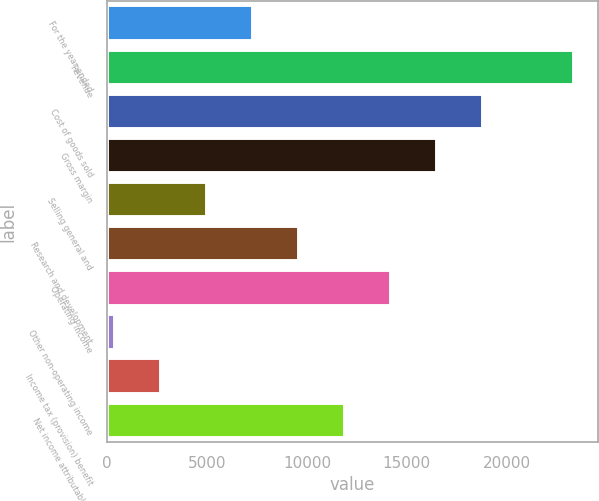Convert chart to OTSL. <chart><loc_0><loc_0><loc_500><loc_500><bar_chart><fcel>For the year ended<fcel>Revenue<fcel>Cost of goods sold<fcel>Gross margin<fcel>Selling general and<fcel>Research and development<fcel>Operating income<fcel>Other non-operating income<fcel>Income tax (provision) benefit<fcel>Net income attributable to<nl><fcel>7305.3<fcel>23406<fcel>18805.8<fcel>16505.7<fcel>5005.2<fcel>9605.4<fcel>14205.6<fcel>405<fcel>2705.1<fcel>11905.5<nl></chart> 